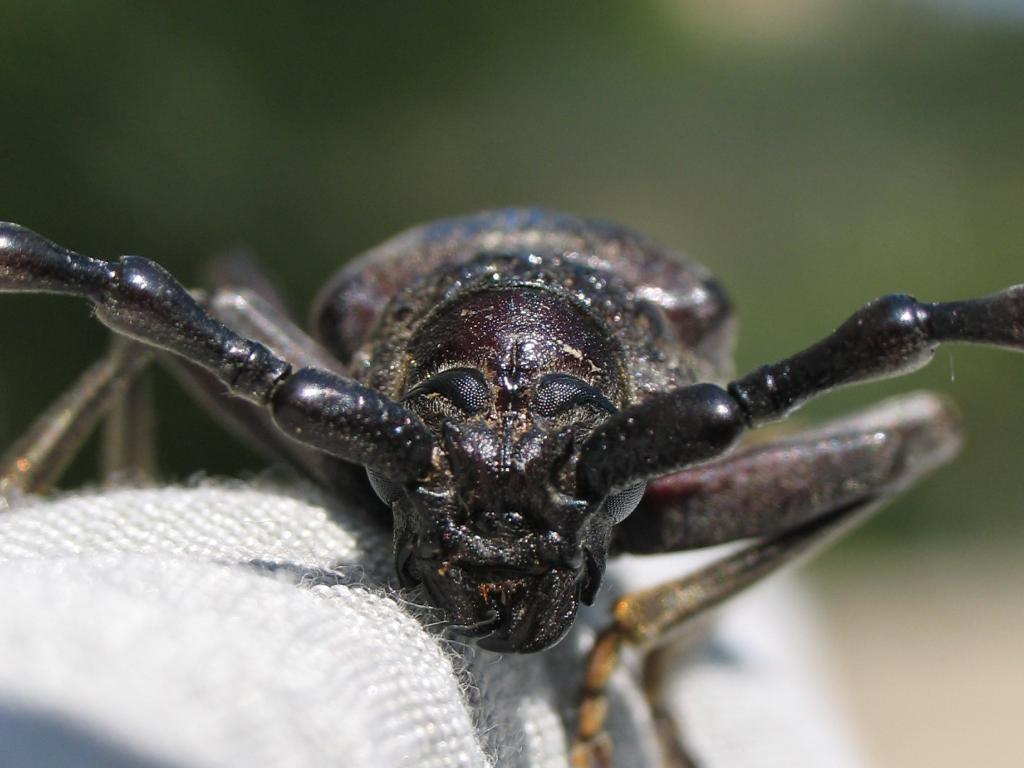What is present in the picture? There is an insect in the picture. Can you describe the insect's appearance? The insect is black in color. What is the insect resting on? The insect is on white color cloth. How would you describe the background of the image? The background of the image is green and blurred. Is there a toothbrush visible in the image? No, there is no toothbrush present in the image. Can you tell me the age of the boy in the image? There is no boy present in the image; it features an insect on white cloth with a green and blurred background. 